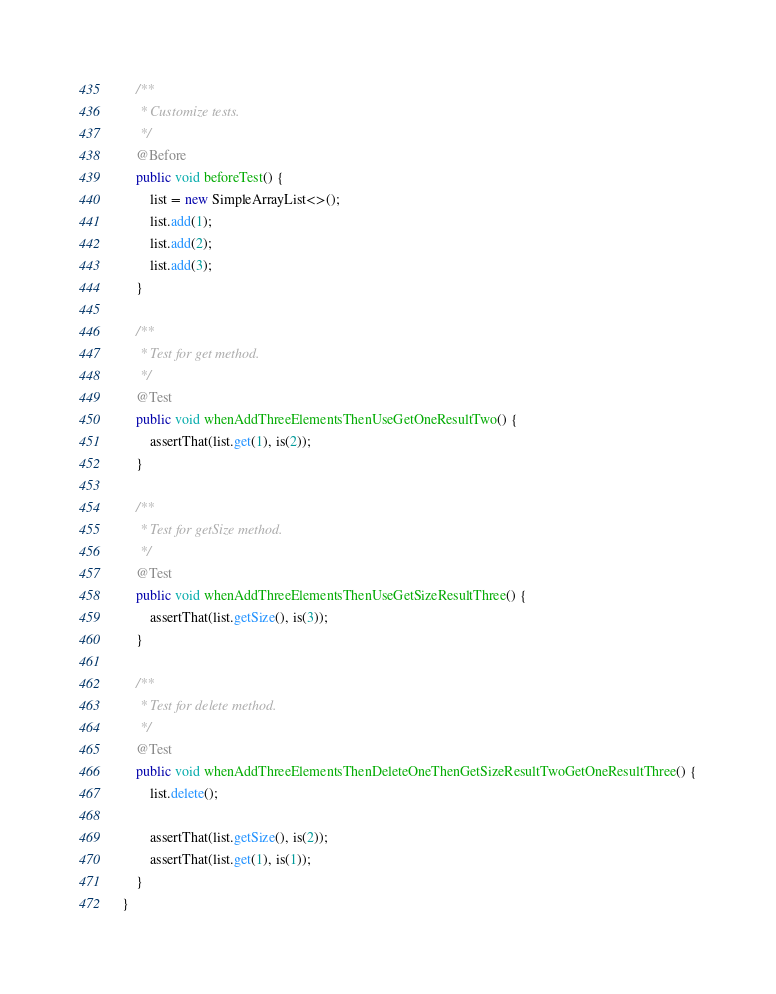Convert code to text. <code><loc_0><loc_0><loc_500><loc_500><_Java_>    /**
     * Customize tests.
     */
    @Before
    public void beforeTest() {
        list = new SimpleArrayList<>();
        list.add(1);
        list.add(2);
        list.add(3);
    }

    /**
     * Test for get method.
     */
    @Test
    public void whenAddThreeElementsThenUseGetOneResultTwo() {
        assertThat(list.get(1), is(2));
    }

    /**
     * Test for getSize method.
     */
    @Test
    public void whenAddThreeElementsThenUseGetSizeResultThree() {
        assertThat(list.getSize(), is(3));
    }

    /**
     * Test for delete method.
     */
    @Test
    public void whenAddThreeElementsThenDeleteOneThenGetSizeResultTwoGetOneResultThree() {
        list.delete();

        assertThat(list.getSize(), is(2));
        assertThat(list.get(1), is(1));
    }
}
</code> 